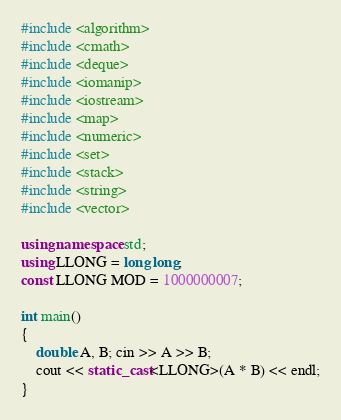<code> <loc_0><loc_0><loc_500><loc_500><_C++_>#include <algorithm>
#include <cmath>
#include <deque>
#include <iomanip>
#include <iostream>
#include <map>
#include <numeric>
#include <set>
#include <stack>
#include <string>
#include <vector>

using namespace std;
using LLONG = long long;
const LLONG MOD = 1000000007;

int main()
{
    double A, B; cin >> A >> B;
    cout << static_cast<LLONG>(A * B) << endl;
}</code> 